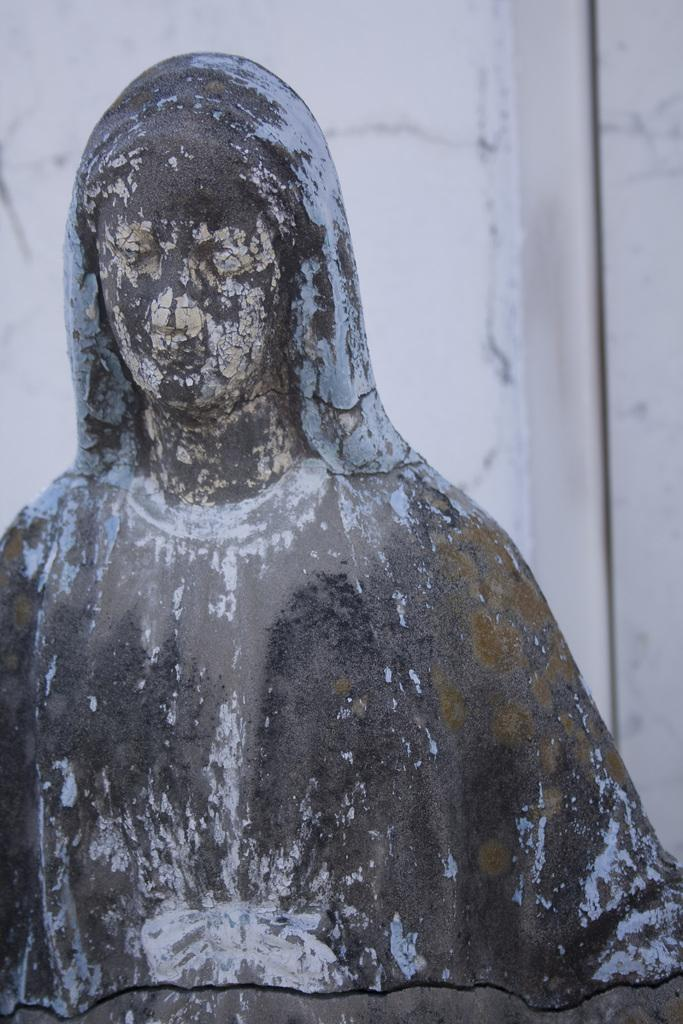What is the main subject of the image? There is a sculpture of a woman in the image. What can be seen behind the sculpture? There is a wall behind the sculpture. What is the color of the wall? The wall is white in color. What type of mark can be seen on the lettuce in the image? There is no lettuce present in the image, and therefore no mark can be observed on it. 